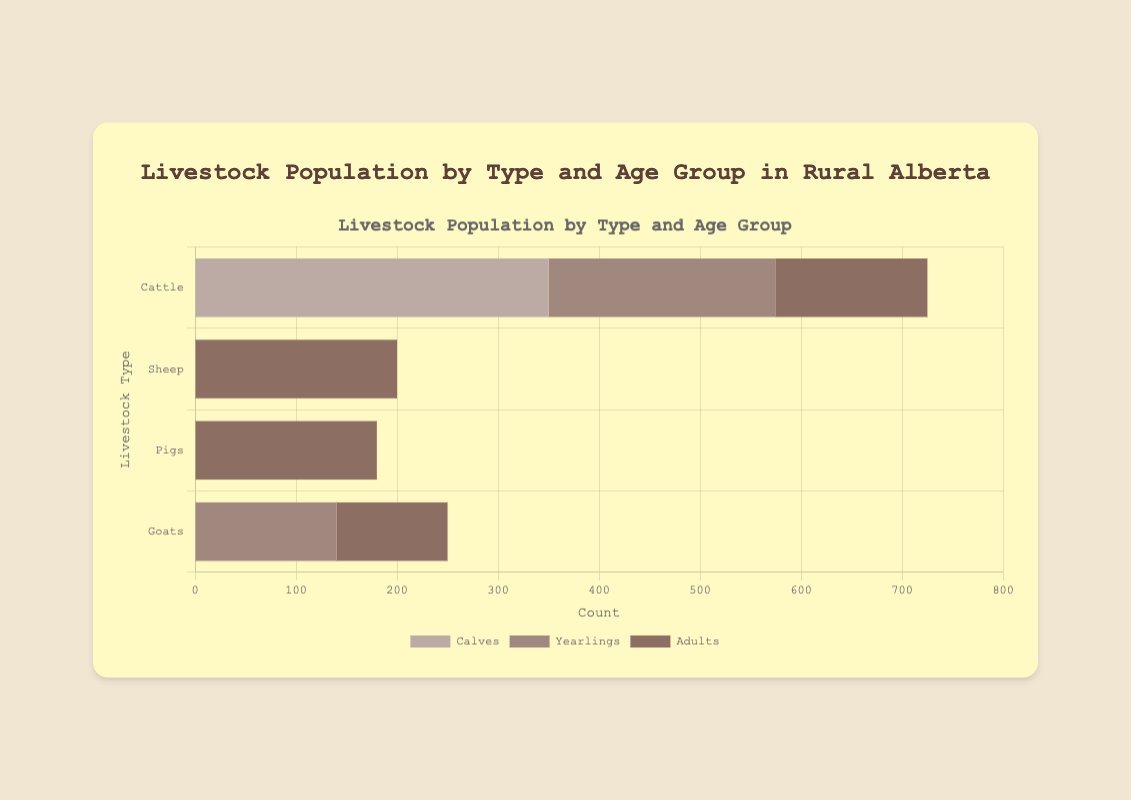Which livestock type has the highest population of adults? By looking at the longest bar in the "Adults" category, it belongs to "Sheep"
Answer: Sheep Which age group of pigs has the largest population? By comparing the lengths of the bars for the different age groups of pigs (Piglets, Juveniles, Adults), the Piglets bar is the longest
Answer: Piglets Which age group in cattle has the smallest population? By comparing the lengths of the bars for the age groups in cattle (Calves, Yearlings, Adults), the Adults bar is the shortest
Answer: Adults How does the population of juvenile pigs compare to juvenile sheep? Compare the lengths of the bars for Juvenile Pigs and Juvenile Sheep, the Juvenile Sheep bar is shorter
Answer: Pigs have a larger population What is the overall population of all goats? Sum the populations of all goats: Kids = 250, Yearlings = 140, Adults = 110. (250 + 140 + 110) = 500
Answer: 500 What is the difference between the population of lambs and calves? Population of Lambs (500) minus the population of Calves (350), which equals (500 - 350) = 150
Answer: 150 Which livestock type has the smallest overall population when summed across all age groups? Sum the populations of all age groups for each livestock type and compare. Goats: (250 + 140 + 110) = 500, smaller than others
Answer: Goats What is the total population of all juvenile livestock across all types? Sum the populations of all juveniles: Yearlings (Cattle) = 225, Juveniles (Sheep) = 300, Juveniles (Pigs) = 320, Yearlings (Goats) = 140. (225 + 300 + 320 + 140) = 985
Answer: 985 How many more piglets are there compared to baby goats? Population of Piglets (450) minus the population of Kids (250) which equals (450 - 250) = 200
Answer: 200 